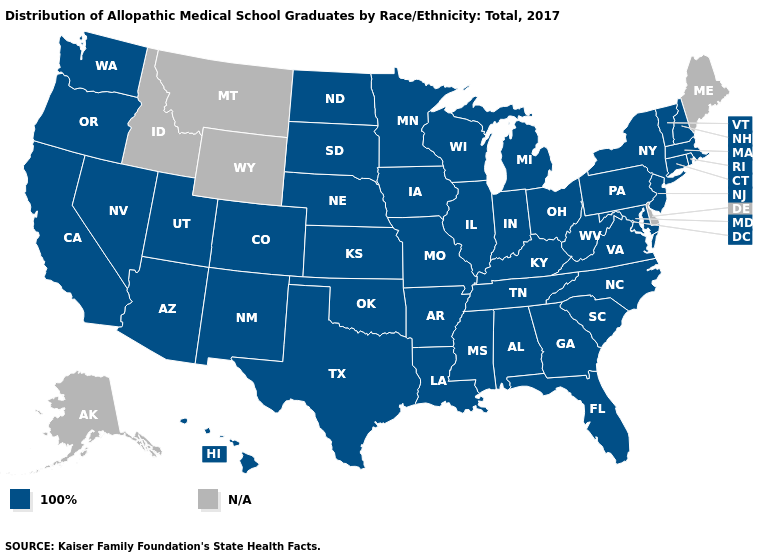Name the states that have a value in the range 100%?
Give a very brief answer. Alabama, Arizona, Arkansas, California, Colorado, Connecticut, Florida, Georgia, Hawaii, Illinois, Indiana, Iowa, Kansas, Kentucky, Louisiana, Maryland, Massachusetts, Michigan, Minnesota, Mississippi, Missouri, Nebraska, Nevada, New Hampshire, New Jersey, New Mexico, New York, North Carolina, North Dakota, Ohio, Oklahoma, Oregon, Pennsylvania, Rhode Island, South Carolina, South Dakota, Tennessee, Texas, Utah, Vermont, Virginia, Washington, West Virginia, Wisconsin. Does the first symbol in the legend represent the smallest category?
Be succinct. Yes. What is the lowest value in states that border Georgia?
Give a very brief answer. 100%. What is the highest value in the Northeast ?
Give a very brief answer. 100%. Does the first symbol in the legend represent the smallest category?
Give a very brief answer. Yes. Name the states that have a value in the range N/A?
Quick response, please. Alaska, Delaware, Idaho, Maine, Montana, Wyoming. Which states have the highest value in the USA?
Write a very short answer. Alabama, Arizona, Arkansas, California, Colorado, Connecticut, Florida, Georgia, Hawaii, Illinois, Indiana, Iowa, Kansas, Kentucky, Louisiana, Maryland, Massachusetts, Michigan, Minnesota, Mississippi, Missouri, Nebraska, Nevada, New Hampshire, New Jersey, New Mexico, New York, North Carolina, North Dakota, Ohio, Oklahoma, Oregon, Pennsylvania, Rhode Island, South Carolina, South Dakota, Tennessee, Texas, Utah, Vermont, Virginia, Washington, West Virginia, Wisconsin. Name the states that have a value in the range N/A?
Answer briefly. Alaska, Delaware, Idaho, Maine, Montana, Wyoming. Name the states that have a value in the range N/A?
Answer briefly. Alaska, Delaware, Idaho, Maine, Montana, Wyoming. What is the lowest value in the USA?
Give a very brief answer. 100%. Is the legend a continuous bar?
Short answer required. No. What is the value of Oregon?
Be succinct. 100%. Name the states that have a value in the range N/A?
Short answer required. Alaska, Delaware, Idaho, Maine, Montana, Wyoming. 